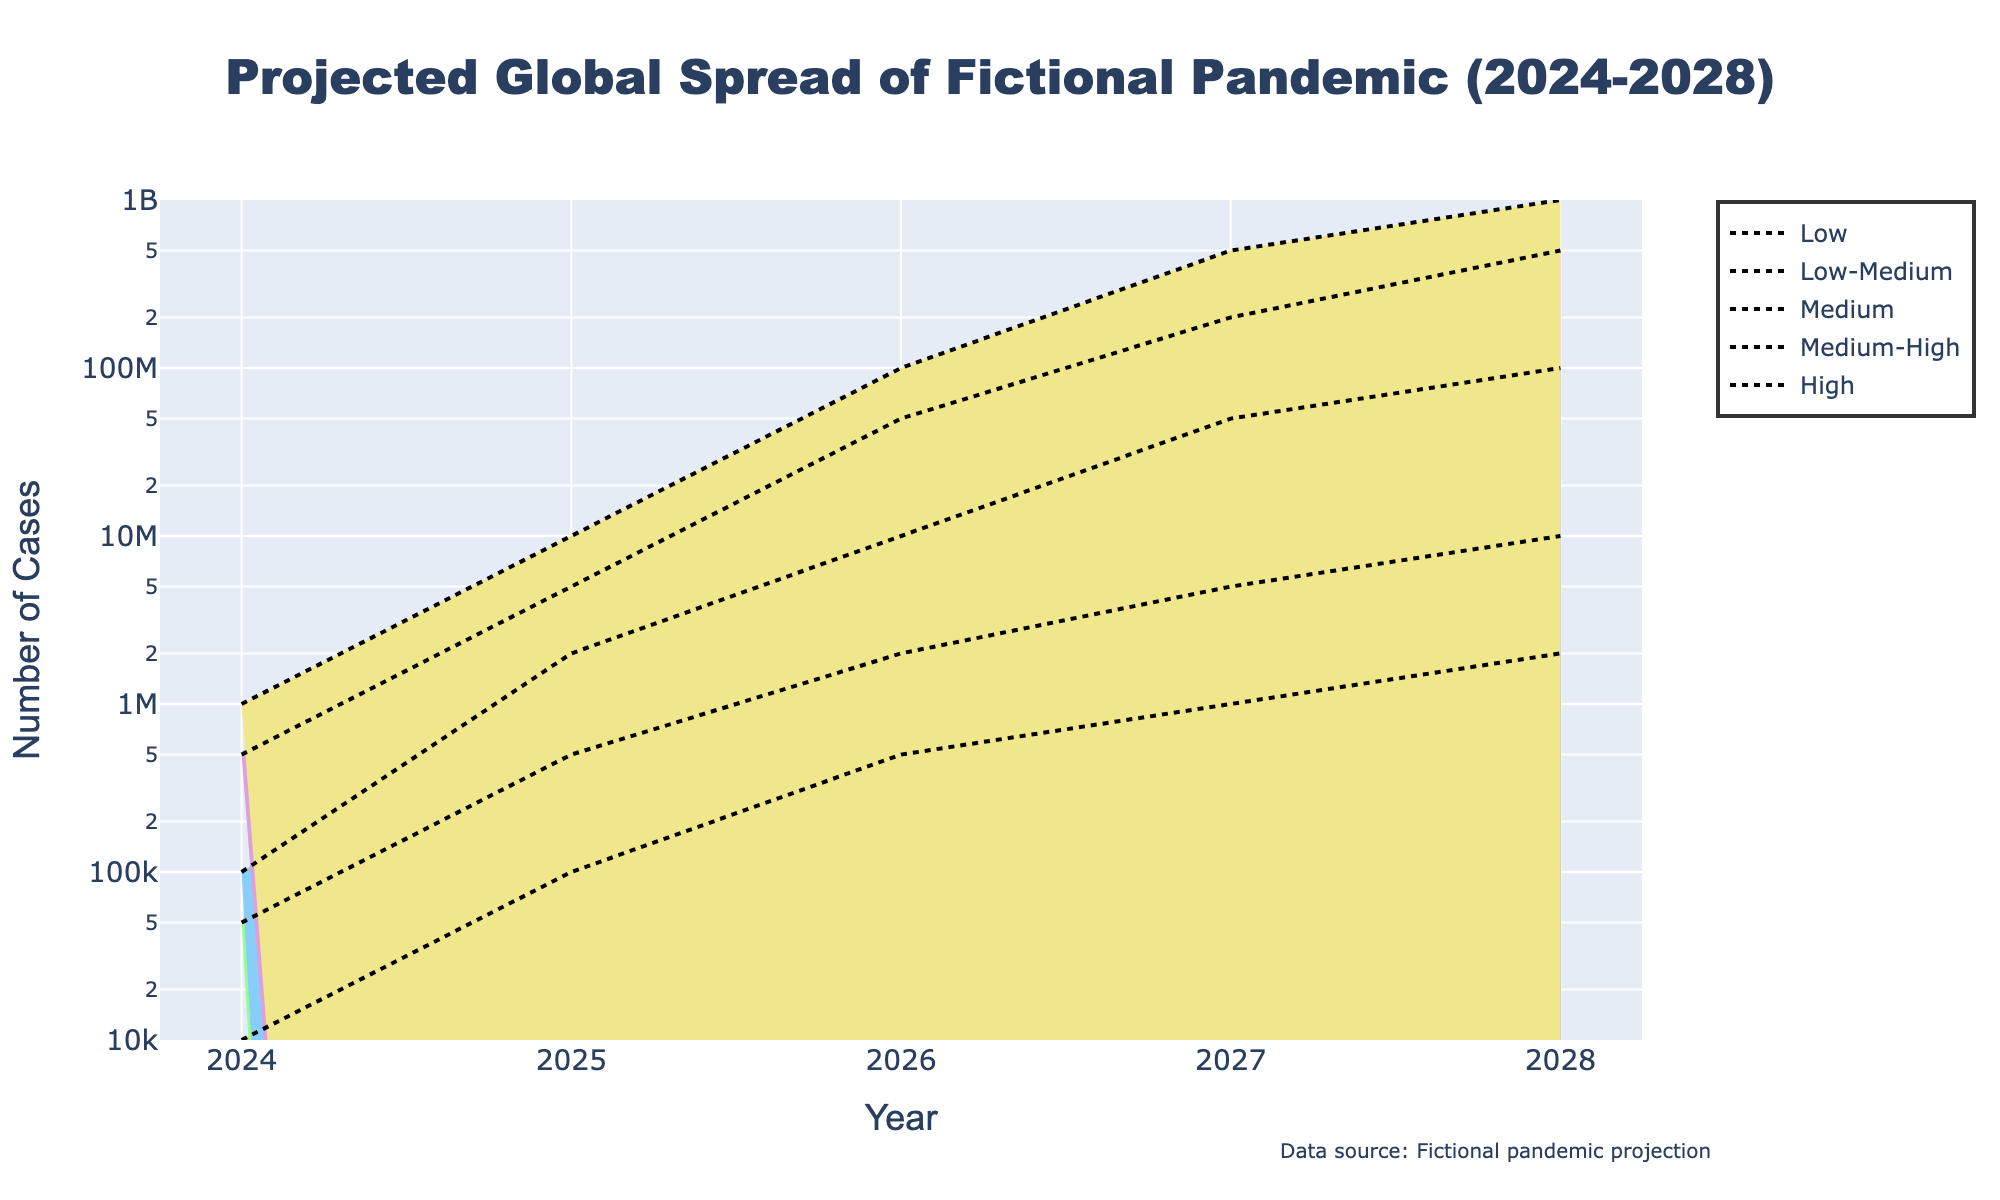What is the title of the figure? The title of the figure is located at the top center and is provided in the larger font.
Answer: Projected Global Spread of Fictional Pandemic (2024-2028) How many severity scenarios are illustrated in the figure? The severity scenarios are depicted as different colored regions within the fan chart.
Answer: Five Which year is projected to have the highest number of cases under the 'High' severity scenario? The 'High' severity scenario line, indicated by the appropriate color, can be examined to locate the maximum value. The year corresponding to this value is 2028.
Answer: 2028 What is the projected number of cases in 2026 for the 'Medium' severity scenario? By following the 'Medium' severity scenario line vertically at the year 2026, we can identify the number of cases.
Answer: 10,000,000 How does the number of cases in the 'Medium-High' scenario in 2027 compare to the 'Low-Medium' scenario in the same year? Locate the number of cases for 2027 in both the 'Medium-High' and 'Low-Medium' scenarios. Compare these values directly.
Answer: 'Medium-High' has significantly more cases than 'Low-Medium' in 2027 Across which range does the figure's y-axis extend? Reference the lower and upper bounds of the y-axis, which are represented in log scale on the figure.
Answer: 10,000 to 1,000,000,000 What is the color associated with the 'Low-Medium' severity scenario? The color assigned to 'Low-Medium' severity can be identified by observing the legend.
Answer: Light green What is the average number of cases projected in 2025 across all severity scenarios? Sum the projections for 2025 across all severity scenarios (100,000 + 500,000 + 2,000,000 + 5,000,000 + 10,000,000) and divide by the number of scenarios (5).
Answer: 3,720,000 Which scenario appears to have the steepest increase in the number of cases from 2024 to 2028? Observe and compare the slope of the lines for each severity scenario between 2024 and 2028. The steepness of the slope indicates the scenario with the most rapid increase.
Answer: High What does the 'y' range on the y-axis mean in terms of cases? The 'y' range on the y-axis uses a logarithmic scale, spanning from 10^4 to 10^9, which translates to the number of cases between 10,000 and 1,000,000,000.
Answer: 10,000 to 1,000,000,000 